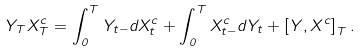<formula> <loc_0><loc_0><loc_500><loc_500>Y _ { T } X _ { T } ^ { c } = \int _ { 0 } ^ { T } Y _ { t - } d X _ { t } ^ { c } + \int _ { 0 } ^ { T } X _ { t - } ^ { c } d Y _ { t } + \left [ Y , X ^ { c } \right ] _ { T } .</formula> 